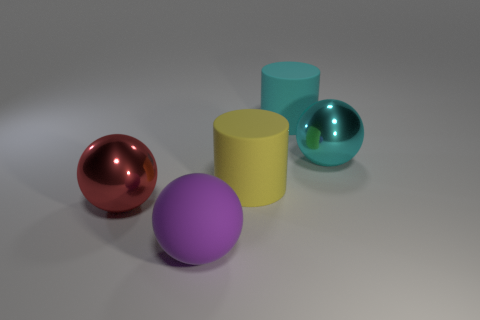Add 4 tiny cyan shiny blocks. How many objects exist? 9 Subtract all yellow spheres. Subtract all gray blocks. How many spheres are left? 3 Subtract all cylinders. How many objects are left? 3 Subtract 0 red cylinders. How many objects are left? 5 Subtract all cylinders. Subtract all large cyan cylinders. How many objects are left? 2 Add 1 yellow things. How many yellow things are left? 2 Add 4 cyan cylinders. How many cyan cylinders exist? 5 